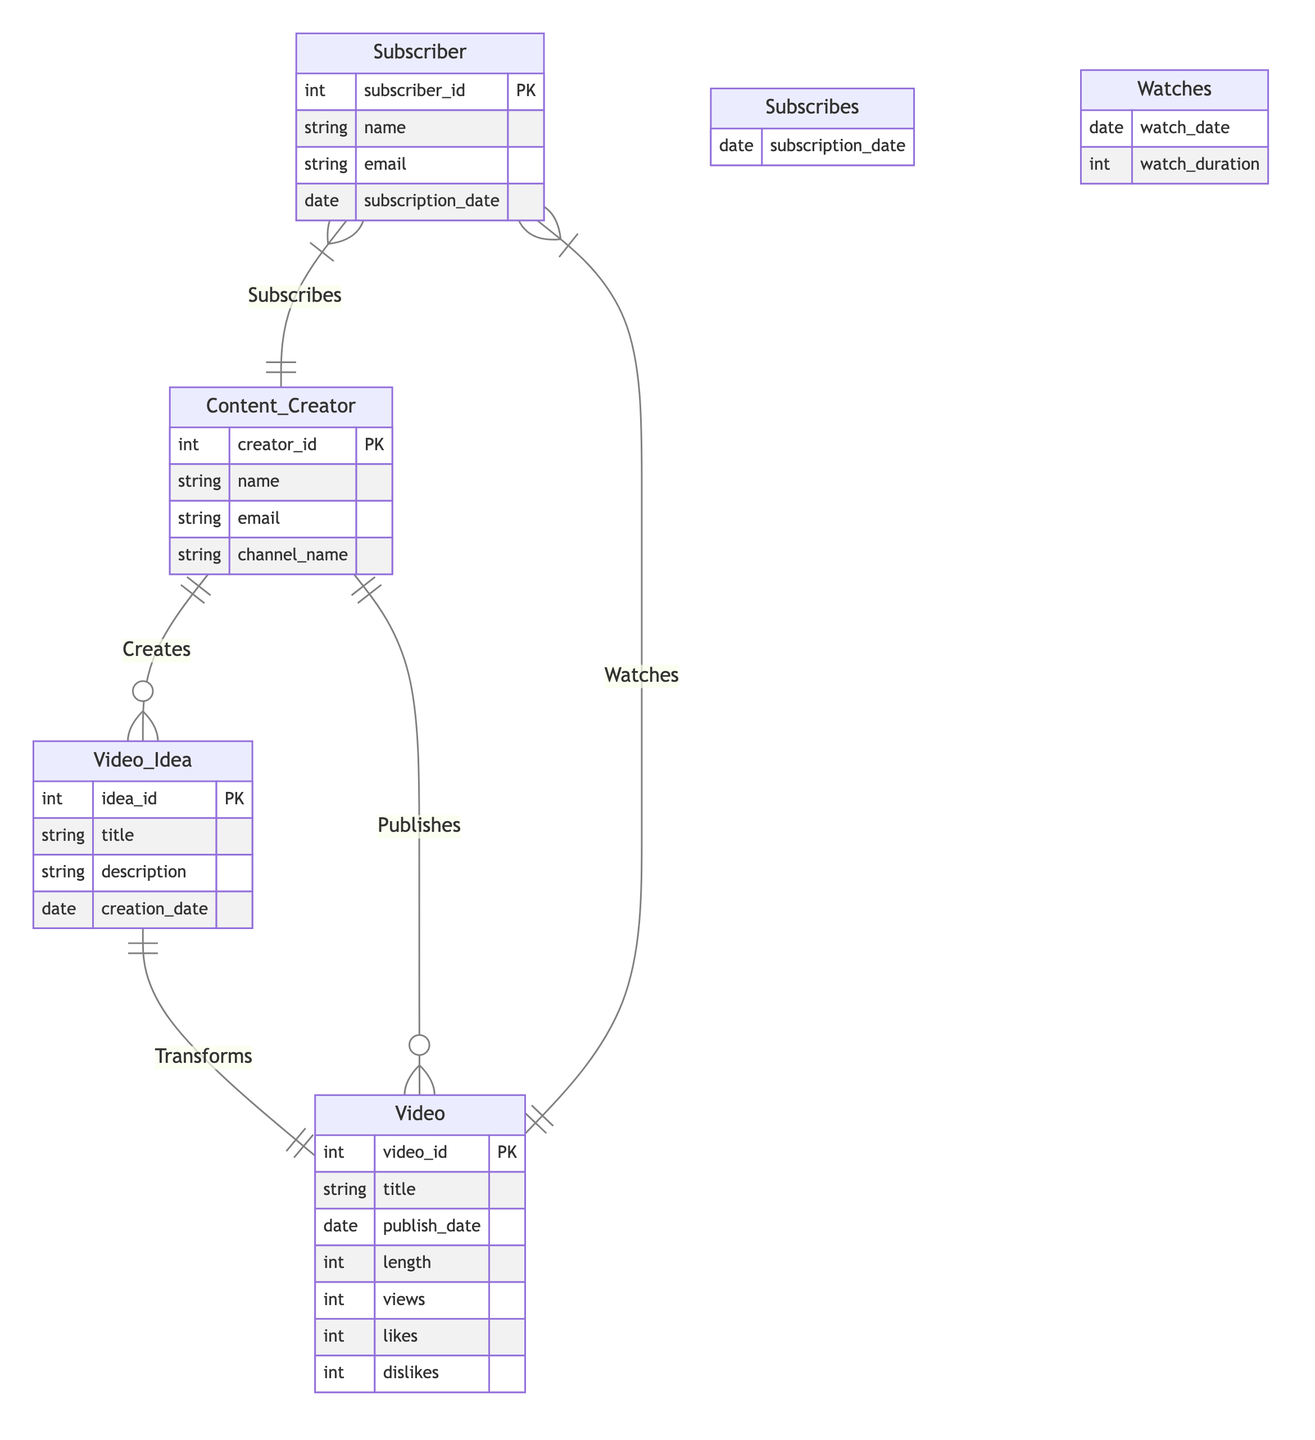What is the primary key of the Content Creator entity? The primary key of the Content Creator entity is creator_id, which uniquely identifies each content creator in the diagram.
Answer: creator_id How many attributes does the Video entity have? The Video entity has six attributes: video_id, title, publish_date, length, views, likes, and dislikes.
Answer: six What type of relationship exists between Video Idea and Video? The relationship between Video Idea and Video is one-to-one, indicating that each video idea transforms into exactly one video.
Answer: one-to-one Which entity is related to Subscriber through a many-to-many relationship? The Subscriber entity is related to Content Creator and Video through many-to-many relationships, where subscribers can subscribe to multiple creators and watch multiple videos.
Answer: Content Creator and Video What additional information is included in the Watches relationship? The Watches relationship includes watch_date and watch_duration, which provide details about when the subscriber watched the video and for how long.
Answer: watch_date and watch_duration How many entities are depicted in the diagram? The diagram depicts four entities: Content Creator, Video Idea, Video, and Subscriber.
Answer: four What is the relationship name between Subscriber and Content Creator? The relationship name between Subscriber and Content Creator is "Subscribes," indicating the action of subscribers signing up for content from creators.
Answer: Subscribes What kind of relationship exists between Content Creator and Video? The relationship between Content Creator and Video is one-to-many, meaning a content creator can publish multiple videos.
Answer: one-to-many Which entity can have a description attribute? The Video Idea entity can have a description attribute, which provides additional context about the video idea.
Answer: Video Idea 